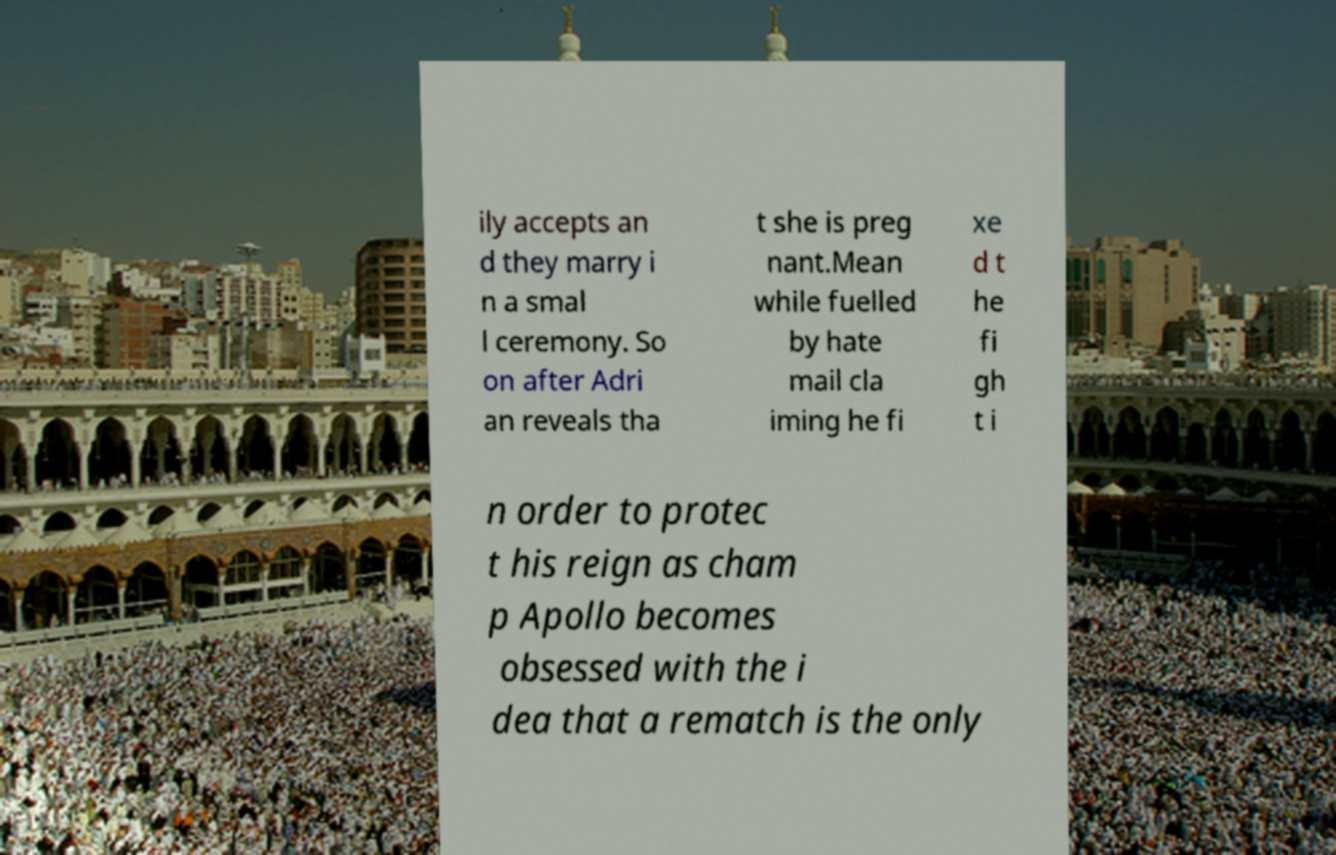Please read and relay the text visible in this image. What does it say? ily accepts an d they marry i n a smal l ceremony. So on after Adri an reveals tha t she is preg nant.Mean while fuelled by hate mail cla iming he fi xe d t he fi gh t i n order to protec t his reign as cham p Apollo becomes obsessed with the i dea that a rematch is the only 